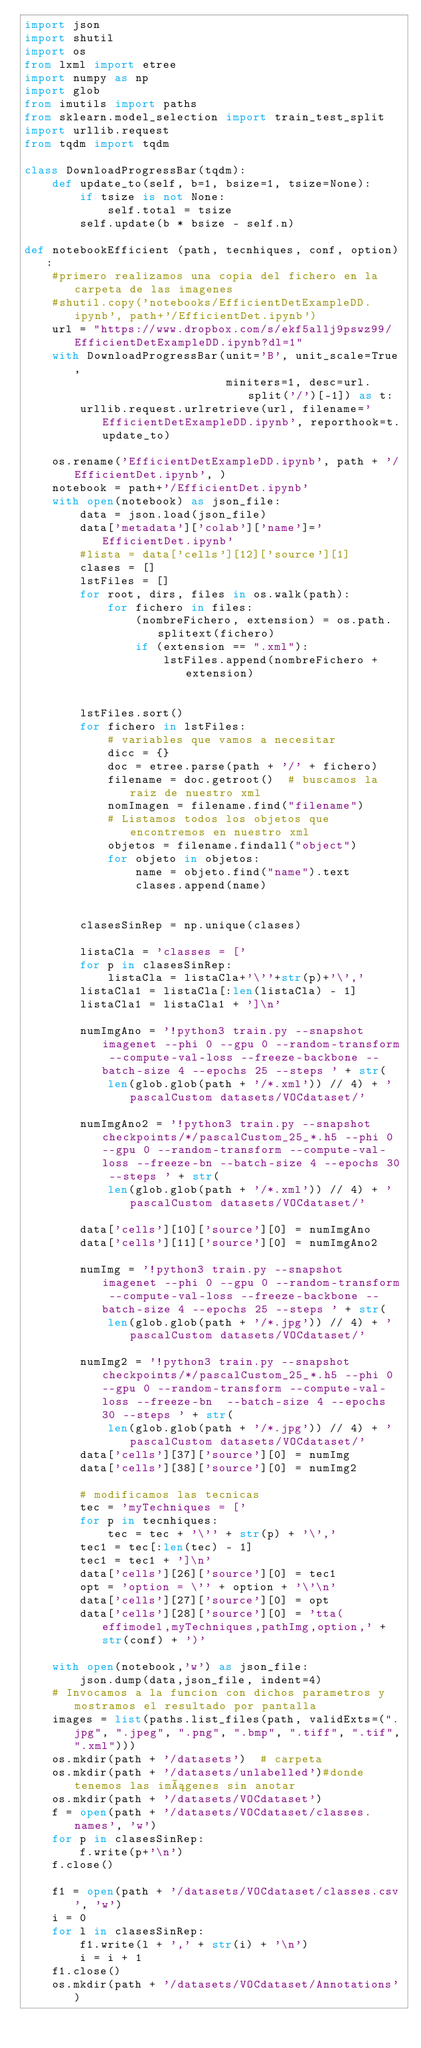<code> <loc_0><loc_0><loc_500><loc_500><_Python_>import json
import shutil
import os
from lxml import etree
import numpy as np
import glob
from imutils import paths
from sklearn.model_selection import train_test_split
import urllib.request
from tqdm import tqdm

class DownloadProgressBar(tqdm):
    def update_to(self, b=1, bsize=1, tsize=None):
        if tsize is not None:
            self.total = tsize
        self.update(b * bsize - self.n)

def notebookEfficient (path, tecnhiques, conf, option):
    #primero realizamos una copia del fichero en la carpeta de las imagenes
    #shutil.copy('notebooks/EfficientDetExampleDD.ipynb', path+'/EfficientDet.ipynb')
    url = "https://www.dropbox.com/s/ekf5allj9pswz99/EfficientDetExampleDD.ipynb?dl=1"
    with DownloadProgressBar(unit='B', unit_scale=True,
                             miniters=1, desc=url.split('/')[-1]) as t:
        urllib.request.urlretrieve(url, filename='EfficientDetExampleDD.ipynb', reporthook=t.update_to)

    os.rename('EfficientDetExampleDD.ipynb', path + '/EfficientDet.ipynb', )
    notebook = path+'/EfficientDet.ipynb'
    with open(notebook) as json_file:
        data = json.load(json_file)
        data['metadata']['colab']['name']='EfficientDet.ipynb'
        #lista = data['cells'][12]['source'][1]
        clases = []
        lstFiles = []
        for root, dirs, files in os.walk(path):
            for fichero in files:
                (nombreFichero, extension) = os.path.splitext(fichero)
                if (extension == ".xml"):
                    lstFiles.append(nombreFichero + extension)


        lstFiles.sort()
        for fichero in lstFiles:
            # variables que vamos a necesitar
            dicc = {}
            doc = etree.parse(path + '/' + fichero)
            filename = doc.getroot()  # buscamos la raiz de nuestro xml
            nomImagen = filename.find("filename")
            # Listamos todos los objetos que encontremos en nuestro xml
            objetos = filename.findall("object")
            for objeto in objetos:
                name = objeto.find("name").text
                clases.append(name)


        clasesSinRep = np.unique(clases)

        listaCla = 'classes = ['
        for p in clasesSinRep:
            listaCla = listaCla+'\''+str(p)+'\','
        listaCla1 = listaCla[:len(listaCla) - 1]
        listaCla1 = listaCla1 + ']\n'

        numImgAno = '!python3 train.py --snapshot imagenet --phi 0 --gpu 0 --random-transform --compute-val-loss --freeze-backbone --batch-size 4 --epochs 25 --steps ' + str(
            len(glob.glob(path + '/*.xml')) // 4) + ' pascalCustom datasets/VOCdataset/'

        numImgAno2 = '!python3 train.py --snapshot checkpoints/*/pascalCustom_25_*.h5 --phi 0 --gpu 0 --random-transform --compute-val-loss --freeze-bn --batch-size 4 --epochs 30 --steps ' + str(
            len(glob.glob(path + '/*.xml')) // 4) + ' pascalCustom datasets/VOCdataset/'

        data['cells'][10]['source'][0] = numImgAno
        data['cells'][11]['source'][0] = numImgAno2

        numImg = '!python3 train.py --snapshot imagenet --phi 0 --gpu 0 --random-transform --compute-val-loss --freeze-backbone --batch-size 4 --epochs 25 --steps ' + str(
            len(glob.glob(path + '/*.jpg')) // 4) + ' pascalCustom datasets/VOCdataset/'

        numImg2 = '!python3 train.py --snapshot checkpoints/*/pascalCustom_25_*.h5 --phi 0 --gpu 0 --random-transform --compute-val-loss --freeze-bn  --batch-size 4 --epochs 30 --steps ' + str(
            len(glob.glob(path + '/*.jpg')) // 4) + ' pascalCustom datasets/VOCdataset/'
        data['cells'][37]['source'][0] = numImg
        data['cells'][38]['source'][0] = numImg2

        # modificamos las tecnicas
        tec = 'myTechniques = ['
        for p in tecnhiques:
            tec = tec + '\'' + str(p) + '\','
        tec1 = tec[:len(tec) - 1]
        tec1 = tec1 + ']\n'
        data['cells'][26]['source'][0] = tec1
        opt = 'option = \'' + option + '\'\n'
        data['cells'][27]['source'][0] = opt
        data['cells'][28]['source'][0] = 'tta(effimodel,myTechniques,pathImg,option,' + str(conf) + ')'

    with open(notebook,'w') as json_file:
        json.dump(data,json_file, indent=4)
    # Invocamos a la funcion con dichos parametros y mostramos el resultado por pantalla
    images = list(paths.list_files(path, validExts=(".jpg", ".jpeg", ".png", ".bmp", ".tiff", ".tif",".xml")))
    os.mkdir(path + '/datasets')  # carpeta
    os.mkdir(path + '/datasets/unlabelled')#donde tenemos las imágenes sin anotar
    os.mkdir(path + '/datasets/VOCdataset')
    f = open(path + '/datasets/VOCdataset/classes.names', 'w')
    for p in clasesSinRep:
        f.write(p+'\n')
    f.close()

    f1 = open(path + '/datasets/VOCdataset/classes.csv', 'w')
    i = 0
    for l in clasesSinRep:
        f1.write(l + ',' + str(i) + '\n')
        i = i + 1
    f1.close()
    os.mkdir(path + '/datasets/VOCdataset/Annotations')</code> 